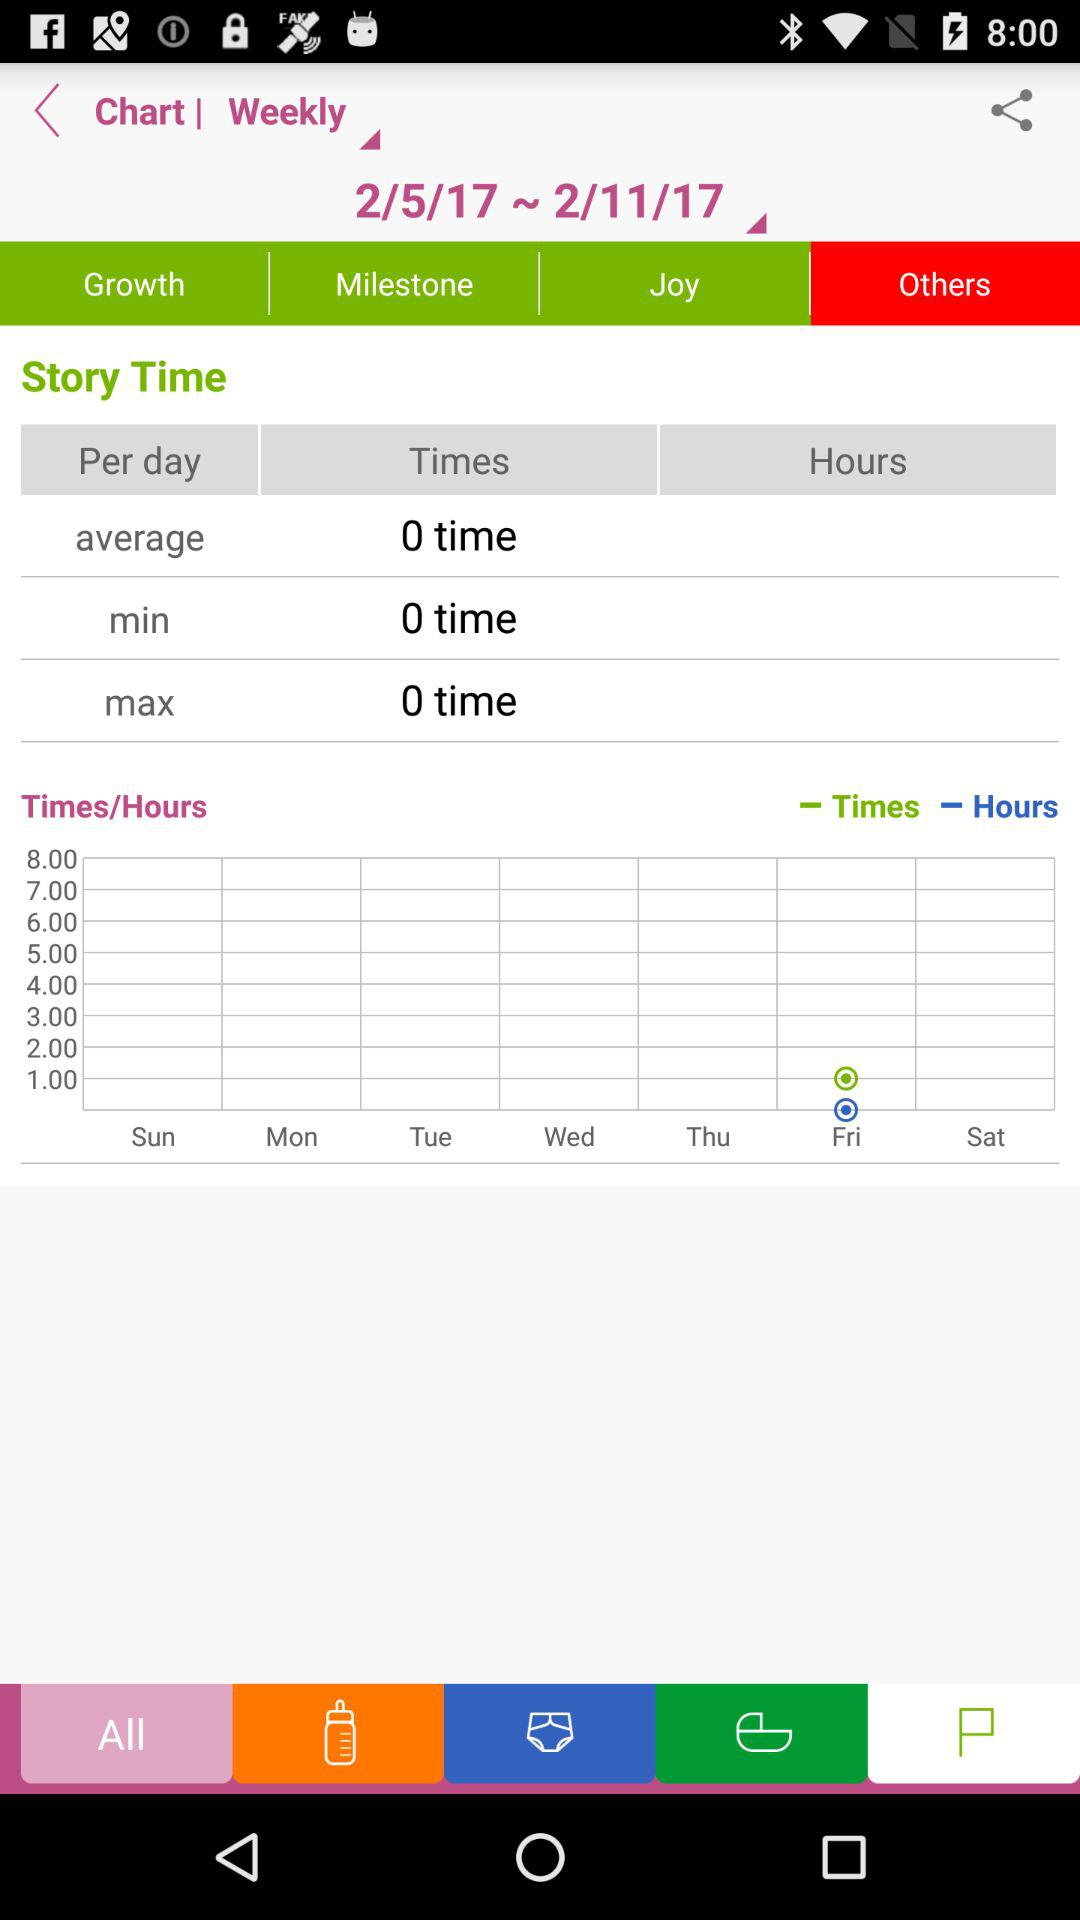What is the average time?
When the provided information is insufficient, respond with <no answer>. <no answer> 